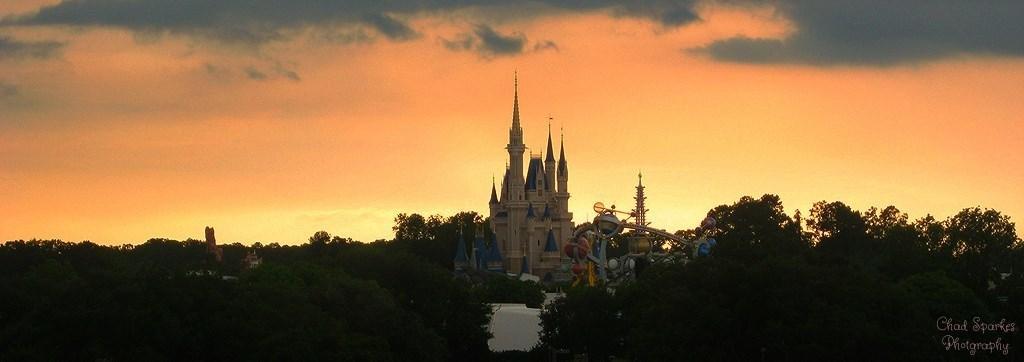Describe this image in one or two sentences. In the center of the image there is a building and we can see a fun ride. In the background there are trees and sky. 